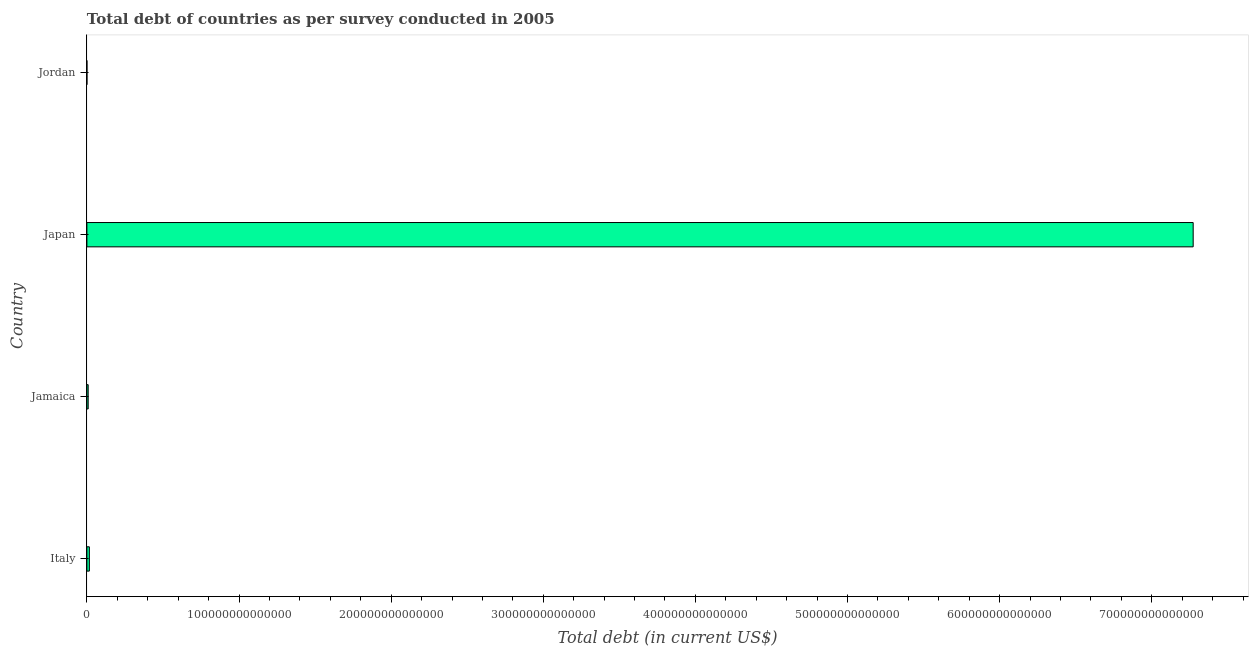Does the graph contain any zero values?
Offer a very short reply. No. Does the graph contain grids?
Ensure brevity in your answer.  No. What is the title of the graph?
Ensure brevity in your answer.  Total debt of countries as per survey conducted in 2005. What is the label or title of the X-axis?
Provide a succinct answer. Total debt (in current US$). What is the label or title of the Y-axis?
Offer a very short reply. Country. What is the total debt in Jordan?
Offer a very short reply. 7.14e+09. Across all countries, what is the maximum total debt?
Your response must be concise. 7.27e+14. Across all countries, what is the minimum total debt?
Your answer should be very brief. 7.14e+09. In which country was the total debt maximum?
Give a very brief answer. Japan. In which country was the total debt minimum?
Provide a short and direct response. Jordan. What is the sum of the total debt?
Offer a terse response. 7.30e+14. What is the difference between the total debt in Jamaica and Jordan?
Your answer should be very brief. 8.40e+11. What is the average total debt per country?
Your answer should be very brief. 1.82e+14. What is the median total debt?
Provide a short and direct response. 1.23e+12. In how many countries, is the total debt greater than 120000000000000 US$?
Your answer should be very brief. 1. What is the ratio of the total debt in Italy to that in Japan?
Make the answer very short. 0. Is the total debt in Italy less than that in Japan?
Provide a short and direct response. Yes. Is the difference between the total debt in Italy and Jamaica greater than the difference between any two countries?
Make the answer very short. No. What is the difference between the highest and the second highest total debt?
Keep it short and to the point. 7.26e+14. What is the difference between the highest and the lowest total debt?
Offer a terse response. 7.27e+14. In how many countries, is the total debt greater than the average total debt taken over all countries?
Ensure brevity in your answer.  1. How many bars are there?
Your answer should be very brief. 4. How many countries are there in the graph?
Ensure brevity in your answer.  4. What is the difference between two consecutive major ticks on the X-axis?
Your answer should be compact. 1.00e+14. Are the values on the major ticks of X-axis written in scientific E-notation?
Give a very brief answer. No. What is the Total debt (in current US$) of Italy?
Provide a succinct answer. 1.62e+12. What is the Total debt (in current US$) in Jamaica?
Provide a succinct answer. 8.47e+11. What is the Total debt (in current US$) of Japan?
Offer a terse response. 7.27e+14. What is the Total debt (in current US$) in Jordan?
Provide a short and direct response. 7.14e+09. What is the difference between the Total debt (in current US$) in Italy and Jamaica?
Make the answer very short. 7.73e+11. What is the difference between the Total debt (in current US$) in Italy and Japan?
Your answer should be very brief. -7.26e+14. What is the difference between the Total debt (in current US$) in Italy and Jordan?
Keep it short and to the point. 1.61e+12. What is the difference between the Total debt (in current US$) in Jamaica and Japan?
Offer a very short reply. -7.26e+14. What is the difference between the Total debt (in current US$) in Jamaica and Jordan?
Offer a very short reply. 8.40e+11. What is the difference between the Total debt (in current US$) in Japan and Jordan?
Provide a succinct answer. 7.27e+14. What is the ratio of the Total debt (in current US$) in Italy to that in Jamaica?
Keep it short and to the point. 1.91. What is the ratio of the Total debt (in current US$) in Italy to that in Japan?
Your response must be concise. 0. What is the ratio of the Total debt (in current US$) in Italy to that in Jordan?
Your response must be concise. 227.05. What is the ratio of the Total debt (in current US$) in Jamaica to that in Japan?
Ensure brevity in your answer.  0. What is the ratio of the Total debt (in current US$) in Jamaica to that in Jordan?
Your response must be concise. 118.74. What is the ratio of the Total debt (in current US$) in Japan to that in Jordan?
Ensure brevity in your answer.  1.02e+05. 